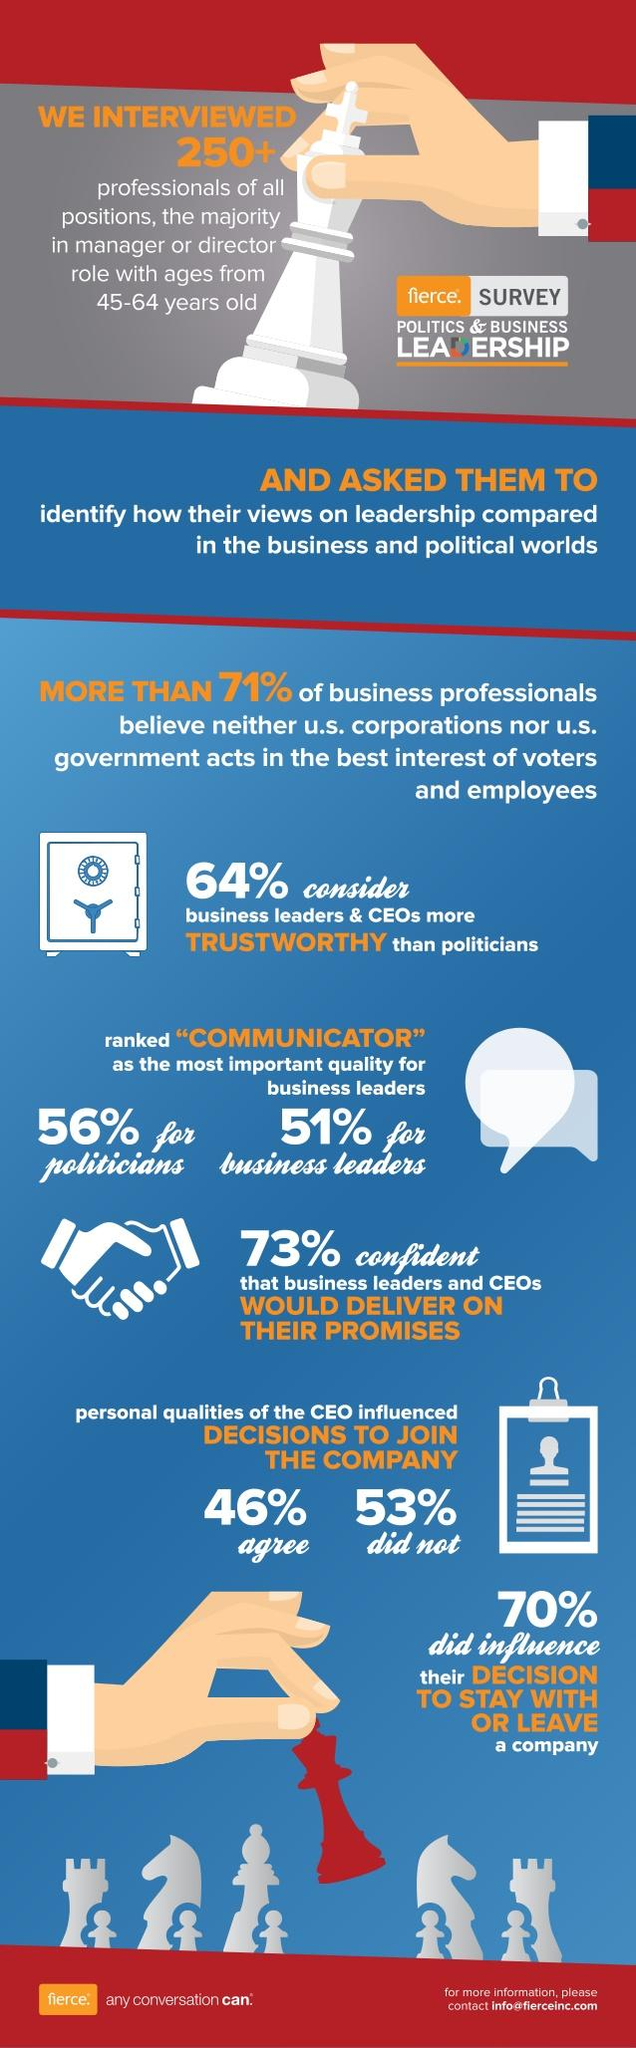Identify some key points in this picture. Nearly half of professionals, 46%, believe that a CEO's personality plays a significant role in their decision to join a company. Trustworthiness was considered the most essential attribute for both political and business leaders, followed closely by communication skills and leadership abilities. 